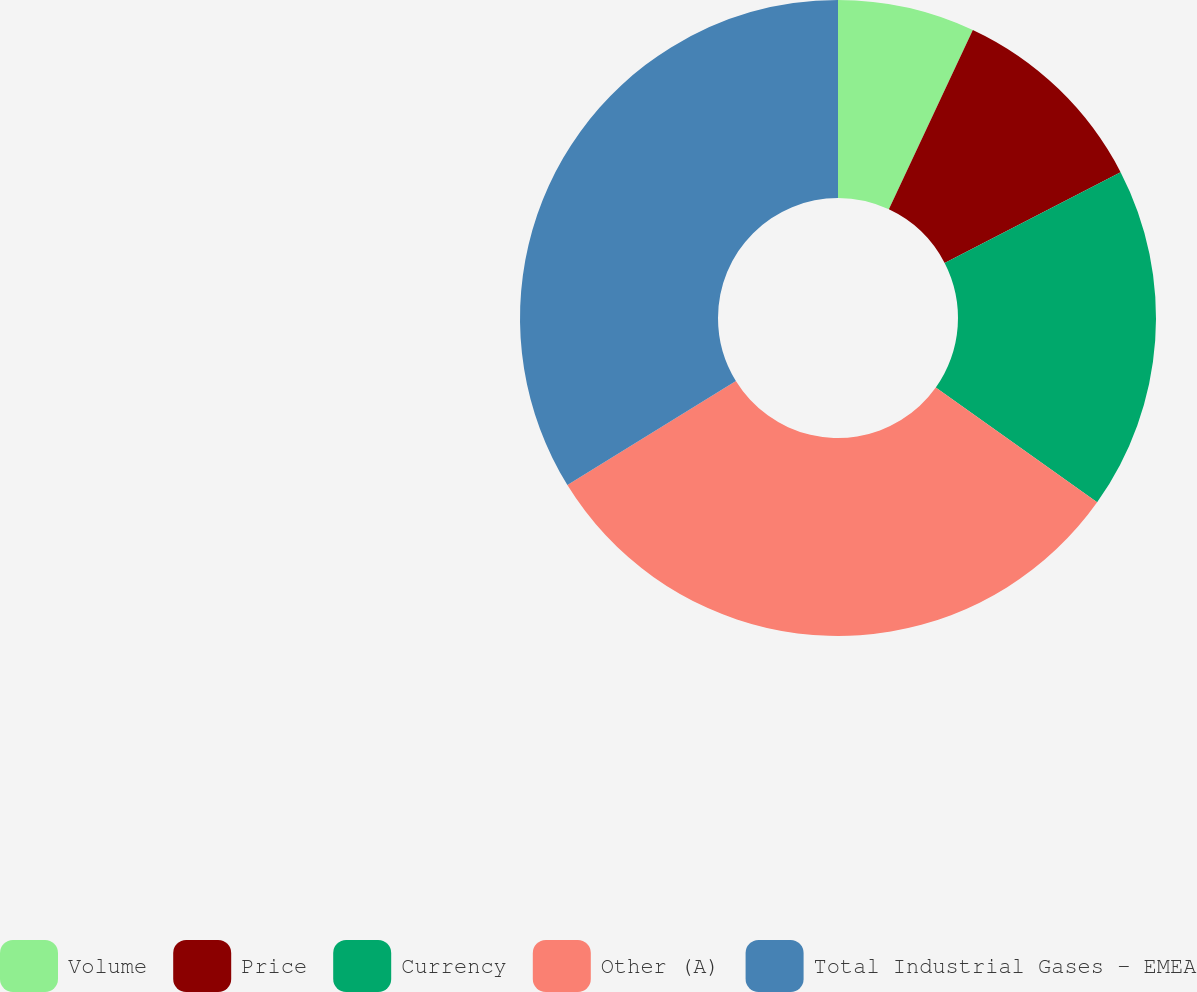<chart> <loc_0><loc_0><loc_500><loc_500><pie_chart><fcel>Volume<fcel>Price<fcel>Currency<fcel>Other (A)<fcel>Total Industrial Gases - EMEA<nl><fcel>6.97%<fcel>10.45%<fcel>17.42%<fcel>31.36%<fcel>33.8%<nl></chart> 